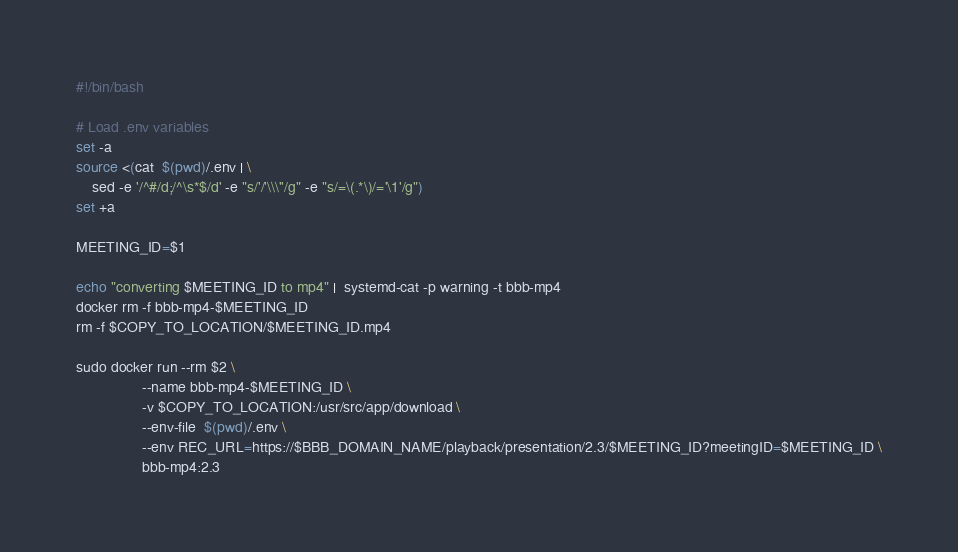<code> <loc_0><loc_0><loc_500><loc_500><_Bash_>#!/bin/bash

# Load .env variables
set -a
source <(cat  $(pwd)/.env | \
    sed -e '/^#/d;/^\s*$/d' -e "s/'/'\\\''/g" -e "s/=\(.*\)/='\1'/g")
set +a

MEETING_ID=$1

echo "converting $MEETING_ID to mp4" |  systemd-cat -p warning -t bbb-mp4
docker rm -f bbb-mp4-$MEETING_ID
rm -f $COPY_TO_LOCATION/$MEETING_ID.mp4

sudo docker run --rm $2 \
                --name bbb-mp4-$MEETING_ID \
                -v $COPY_TO_LOCATION:/usr/src/app/download \
                --env-file  $(pwd)/.env \
                --env REC_URL=https://$BBB_DOMAIN_NAME/playback/presentation/2.3/$MEETING_ID?meetingID=$MEETING_ID \
                bbb-mp4:2.3</code> 